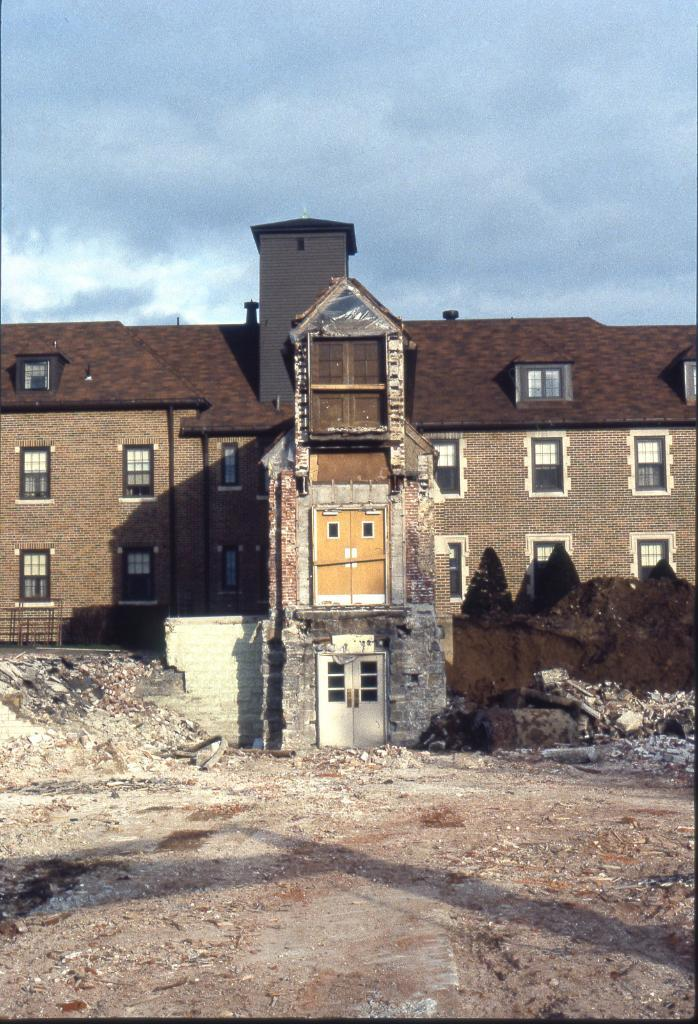What type of structure is visible in the image? There is a building in the image. What features can be seen on the building? The building has windows and doors. Can you see a plane taking off from the roof of the building in the image? There is no plane visible in the image, nor is there any indication that a plane is taking off from the building. 